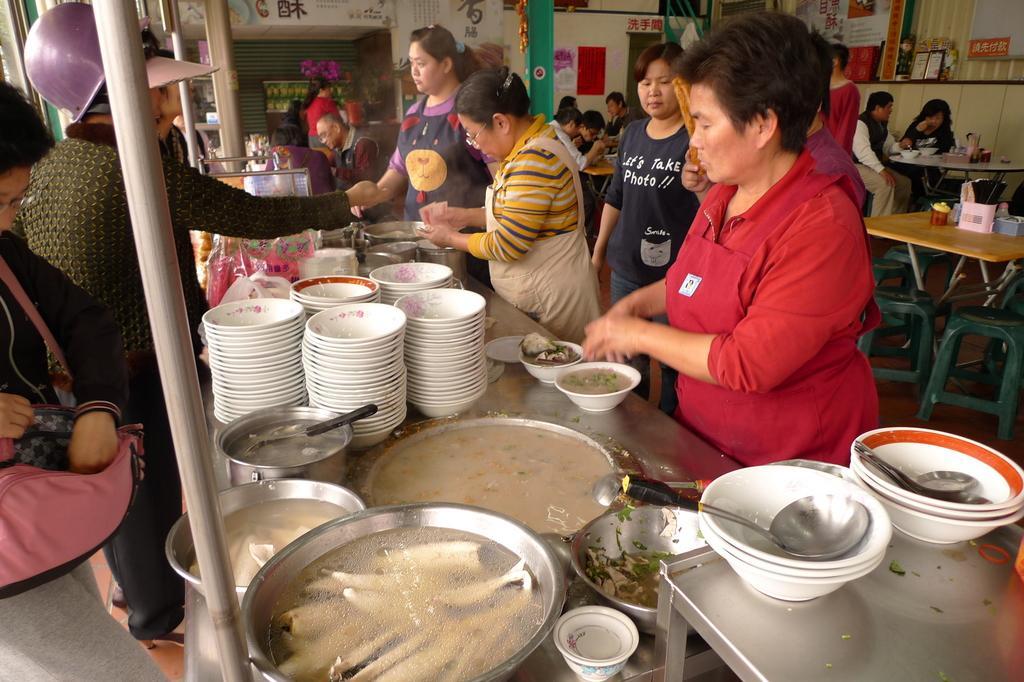How would you summarize this image in a sentence or two? In the center of this picture we can see the group of persons, holding some objects and standing and we can see the tables on the top of which bowls, food items, spoons and many other objects are placed and we can see the group of persons sitting on the chairs. In the background we can see the text on the posters and we can see the flowers, metal rods and many other objects. 